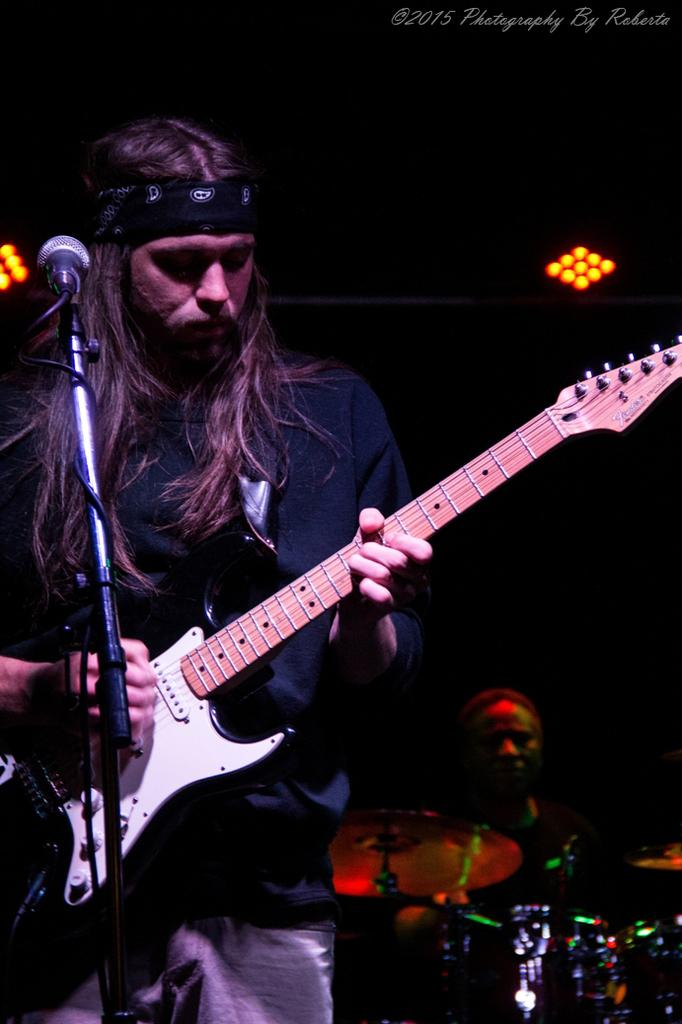What is the main subject of the image? The main subject of the image is a guy holding a guitar. What is the guy with the guitar doing? The guy with the guitar is in front of a microphone. Are there any other musicians in the image? Yes, there is another guy playing drums in the background. What can be seen on the ceiling in the image? There are lights on the ceiling in the image. How many pizzas are being served on the table in the image? There is no table or pizzas present in the image; it features a guy holding a guitar, a microphone, and a drummer in the background. 